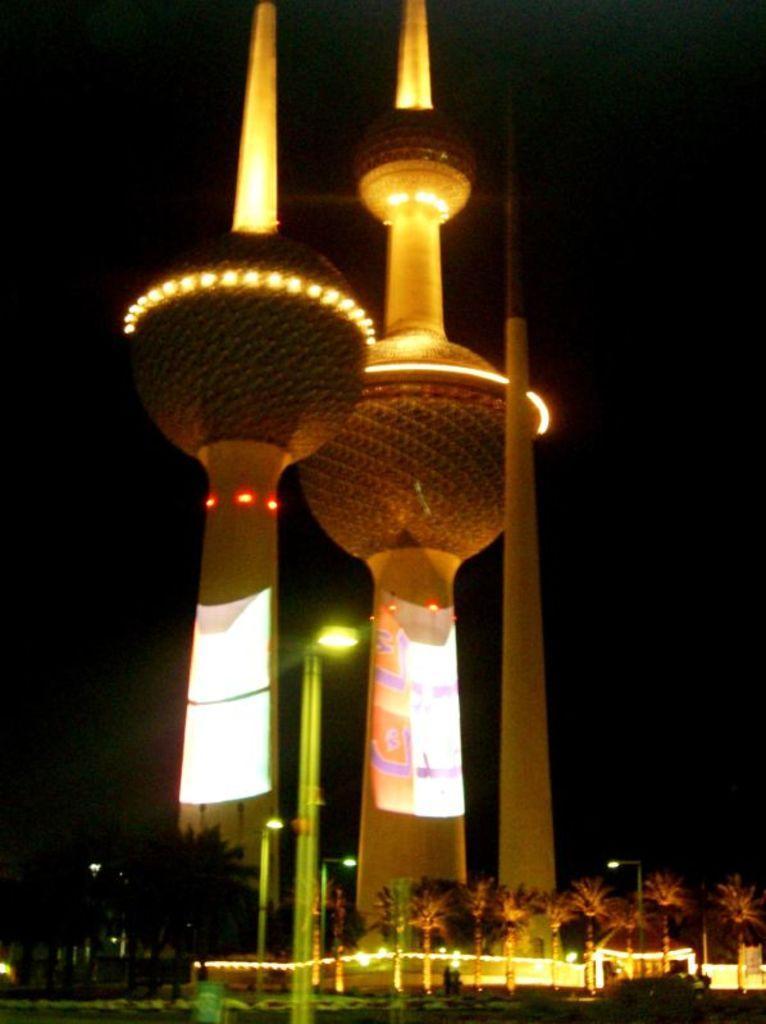In one or two sentences, can you explain what this image depicts? In this picture I can see towers. There are poles, lights, trees, and there is dark background. 